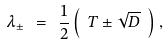Convert formula to latex. <formula><loc_0><loc_0><loc_500><loc_500>\lambda _ { \pm } \ = \ \frac { 1 } { 2 } \left ( \ T \pm \sqrt { D } \ \right ) ,</formula> 